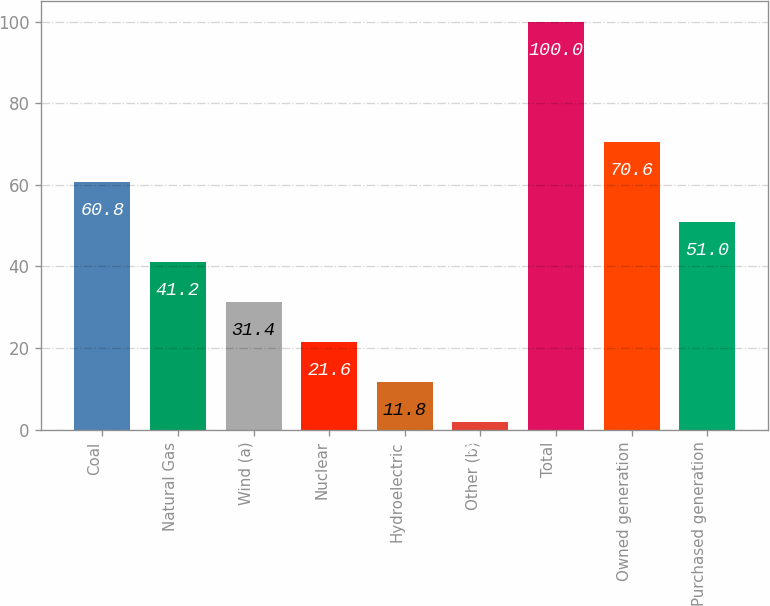Convert chart to OTSL. <chart><loc_0><loc_0><loc_500><loc_500><bar_chart><fcel>Coal<fcel>Natural Gas<fcel>Wind (a)<fcel>Nuclear<fcel>Hydroelectric<fcel>Other (b)<fcel>Total<fcel>Owned generation<fcel>Purchased generation<nl><fcel>60.8<fcel>41.2<fcel>31.4<fcel>21.6<fcel>11.8<fcel>2<fcel>100<fcel>70.6<fcel>51<nl></chart> 